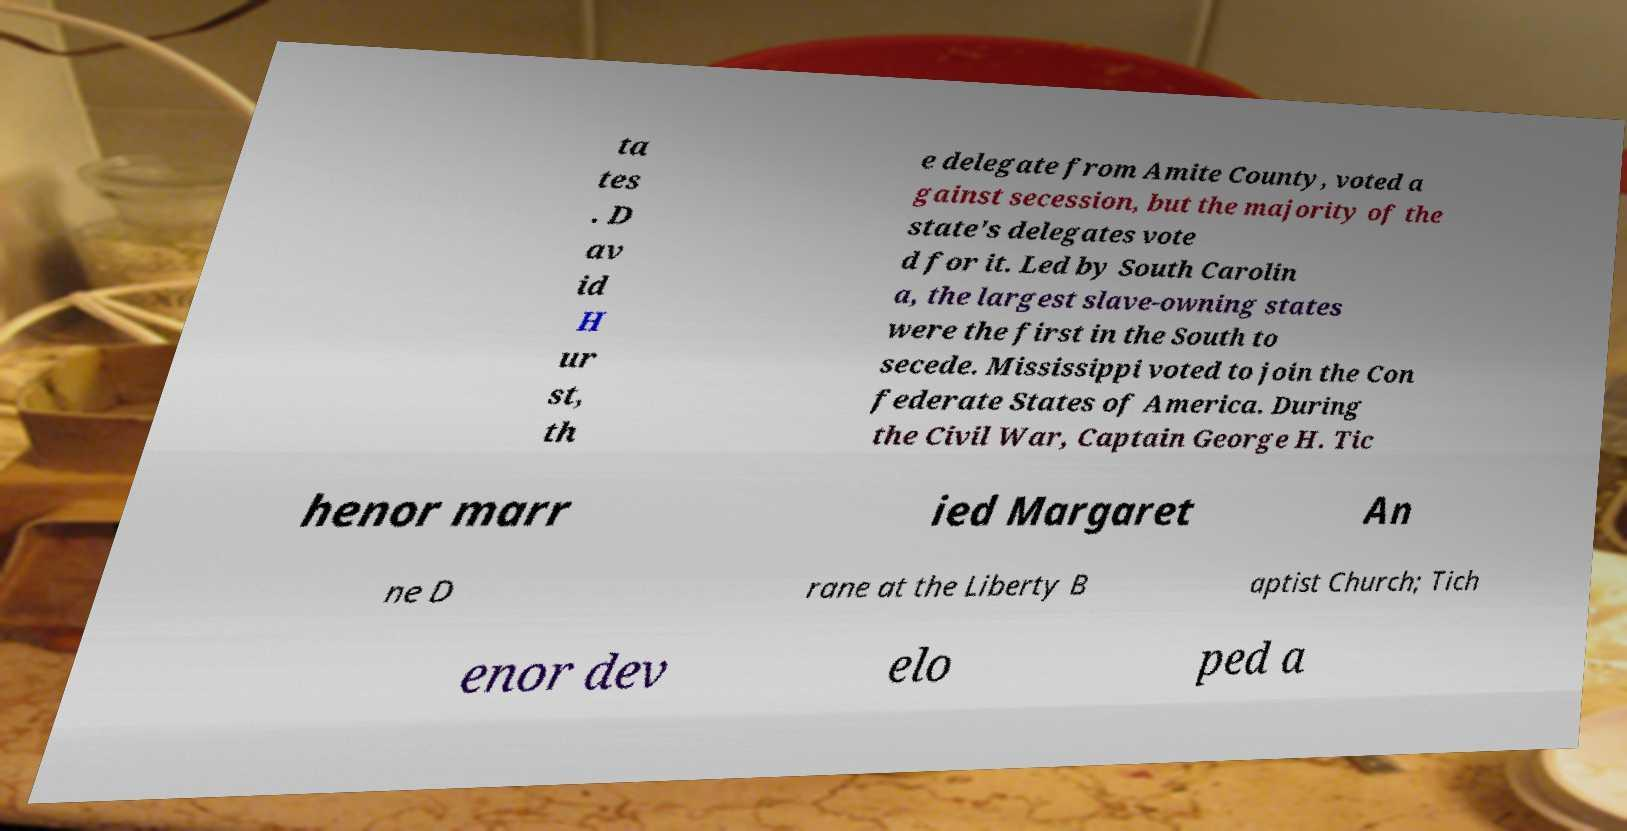Could you extract and type out the text from this image? ta tes . D av id H ur st, th e delegate from Amite County, voted a gainst secession, but the majority of the state's delegates vote d for it. Led by South Carolin a, the largest slave-owning states were the first in the South to secede. Mississippi voted to join the Con federate States of America. During the Civil War, Captain George H. Tic henor marr ied Margaret An ne D rane at the Liberty B aptist Church; Tich enor dev elo ped a 